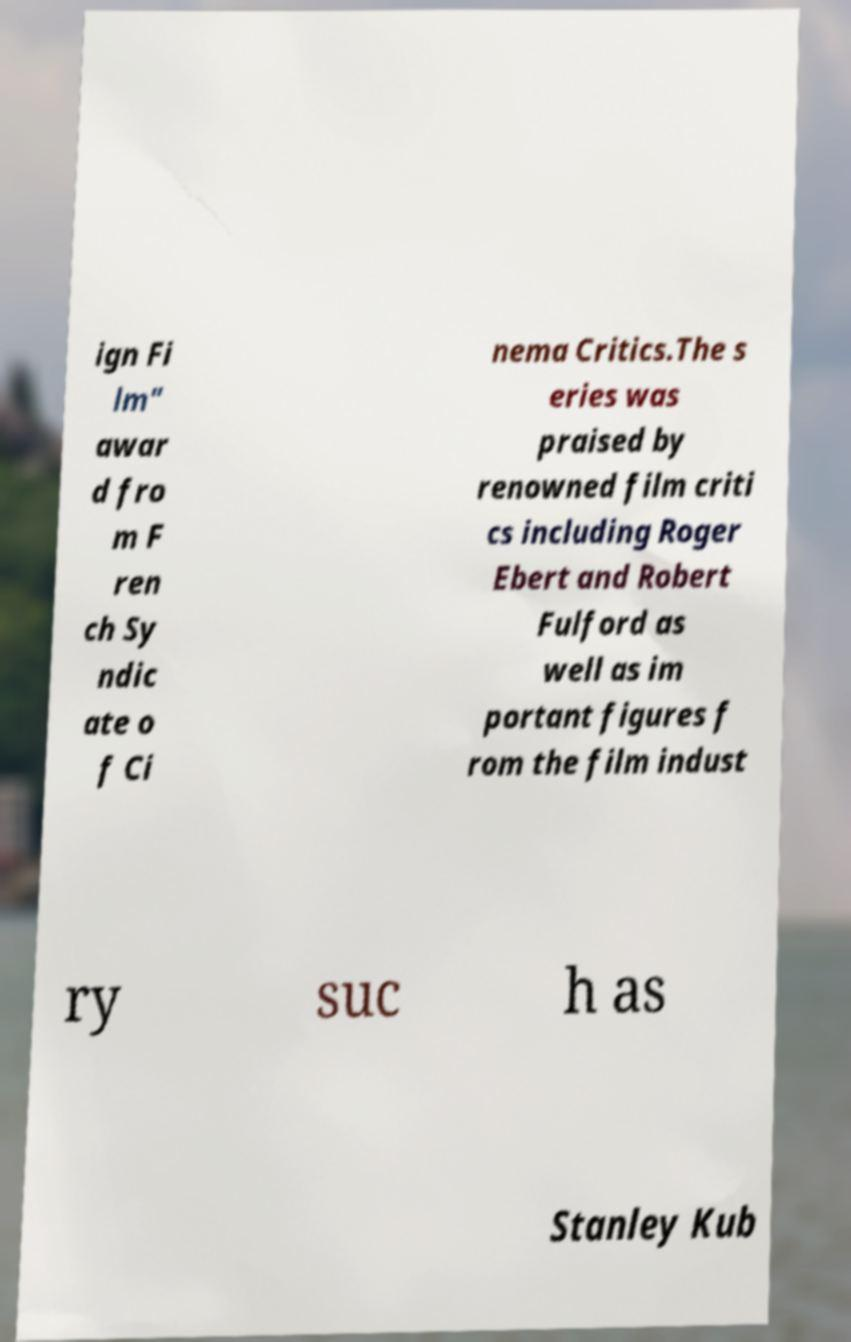I need the written content from this picture converted into text. Can you do that? ign Fi lm" awar d fro m F ren ch Sy ndic ate o f Ci nema Critics.The s eries was praised by renowned film criti cs including Roger Ebert and Robert Fulford as well as im portant figures f rom the film indust ry suc h as Stanley Kub 